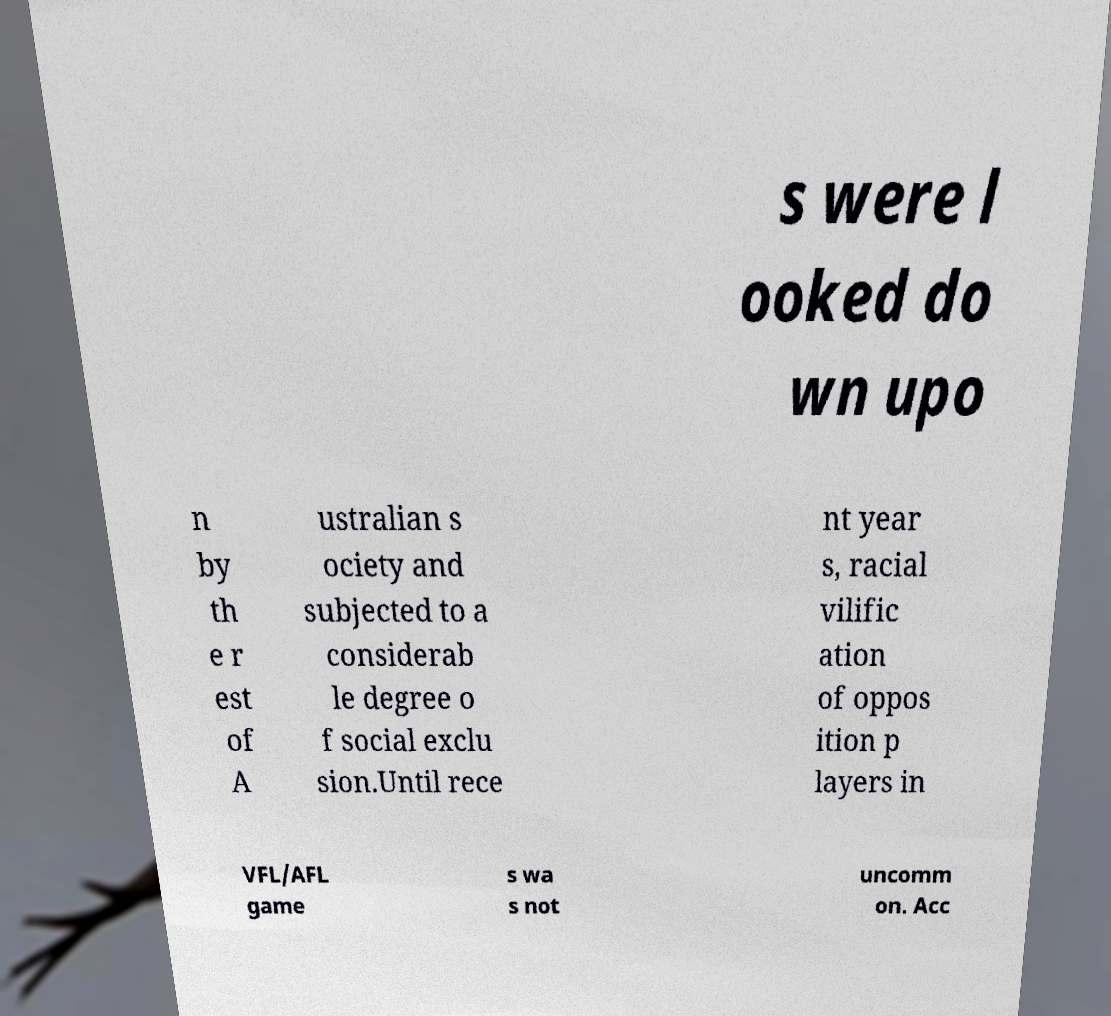Can you accurately transcribe the text from the provided image for me? s were l ooked do wn upo n by th e r est of A ustralian s ociety and subjected to a considerab le degree o f social exclu sion.Until rece nt year s, racial vilific ation of oppos ition p layers in VFL/AFL game s wa s not uncomm on. Acc 